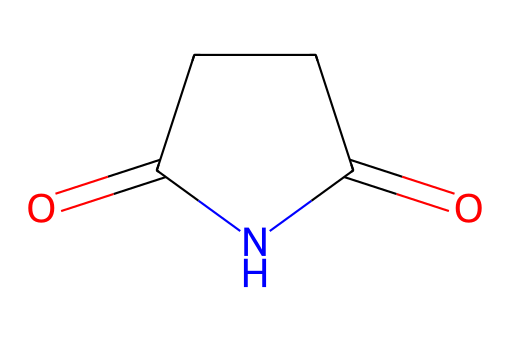how many carbon atoms are in succinimide? By examining the SMILES representation O=C1CCC(=O)N1, we can identify there are four carbon (C) atoms present in the ring structure and the overall molecule.
Answer: four how many nitrogen atoms are present? In the structure from the SMILES O=C1CCC(=O)N1, there is one nitrogen (N) atom indicated.
Answer: one what is the functional group present in succinimide? The SMILES notation contains a carbonyl (C=O) and an amide linkage (N-C), characteristic of imides, specifically showing that it is an imide functional group.
Answer: imide is succinimide a cyclic compound? Observing the ring structure indicated by the numbers in the SMILES (1), which denotes a closed loop, confirms that succinimide is indeed a cyclic compound.
Answer: yes what type of reaction can succinimide undergo? Given its structure, succinimide can participate in hydrolysis leading to the formation of a corresponding carboxylic acid and amine, a characteristic reaction of imides.
Answer: hydrolysis can succinimide be used in water treatment? The chemical properties of succinimide function well in water treatment systems due to its ability to act as a chelating agent, assisting in the removal of metal ions.
Answer: yes 